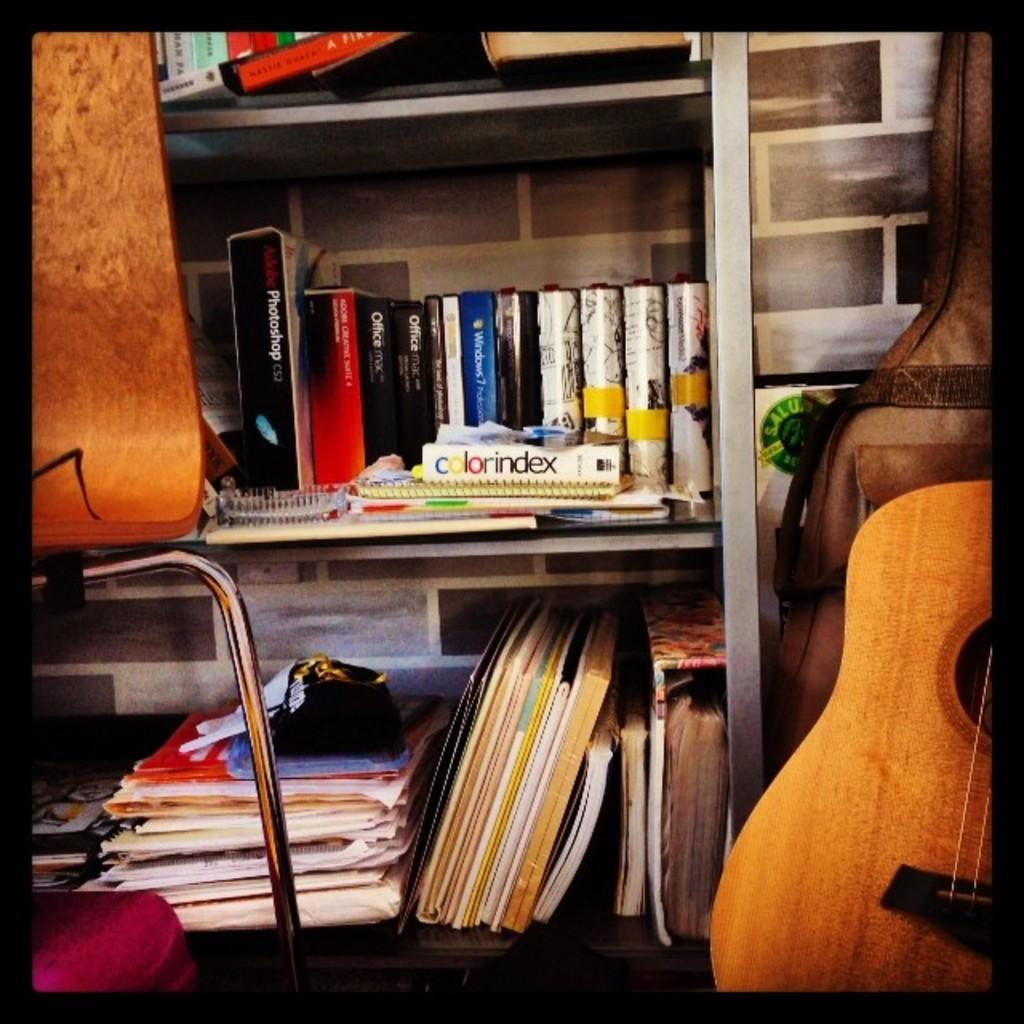<image>
Offer a succinct explanation of the picture presented. A book with the title Colorindex is sitting on a bookshelf with other books. 